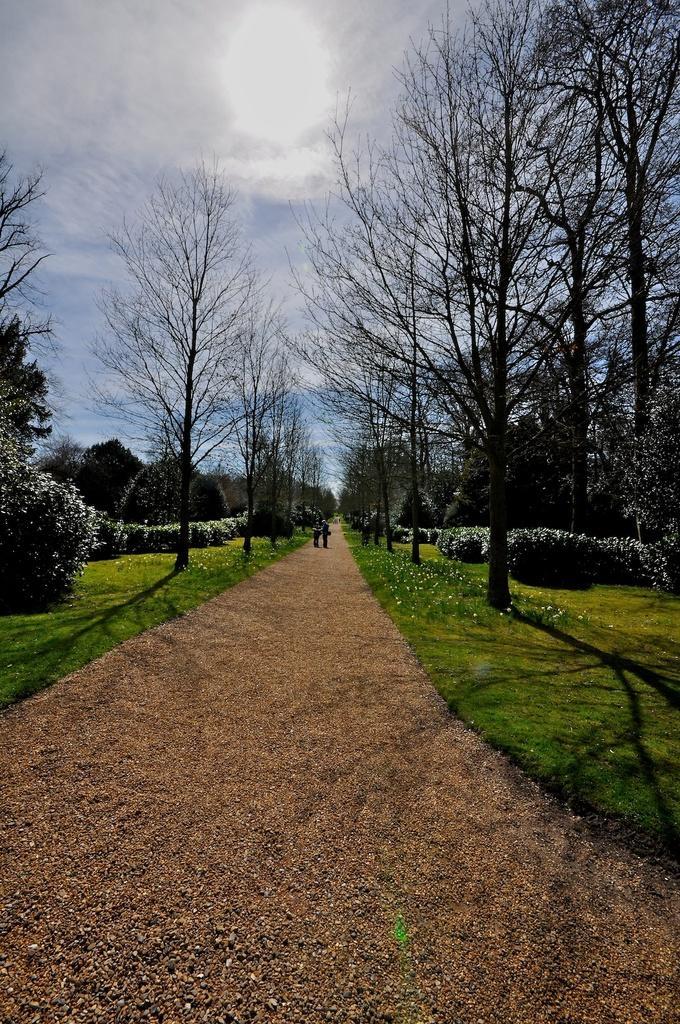Please provide a concise description of this image. In the center of the image there is a walkway and we can see trees and bushes. In the background there is sky. 